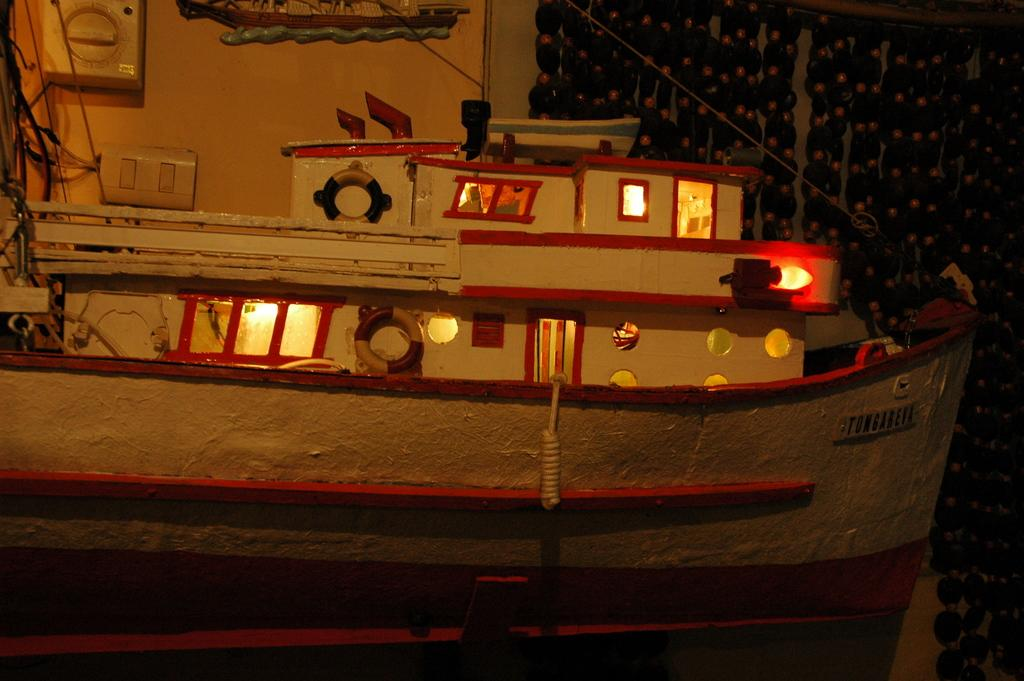What type of structure is depicted in the image? There is an artificial ship in the image. What can be seen in the background of the image? There is a wall in the background of the image. What features are present on the wall? There are switches on the wall. Is there any window treatment associated with the wall? Yes, there is a curtain associated with the wall. What is the taste of the river in the image? There is no river present in the image, so it is not possible to determine its taste. 